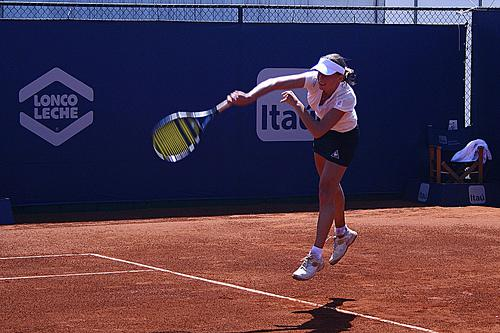Question: what game is being played?
Choices:
A. Basketball.
B. Volleyball.
C. Tennis.
D. Handball.
Answer with the letter. Answer: C Question: where is the game taking place?
Choices:
A. Baseball field.
B. Basketball court.
C. Tennis court.
D. Soccer field.
Answer with the letter. Answer: C Question: who is playing tennis?
Choices:
A. A man.
B. A child.
C. A woman.
D. A grandmother.
Answer with the letter. Answer: C Question: how many people on the tennis court?
Choices:
A. 2.
B. 3.
C. 1.
D. 4.
Answer with the letter. Answer: C Question: when was the photo taken?
Choices:
A. Nighttime.
B. Afternoon.
C. Morning.
D. Daytime.
Answer with the letter. Answer: D 